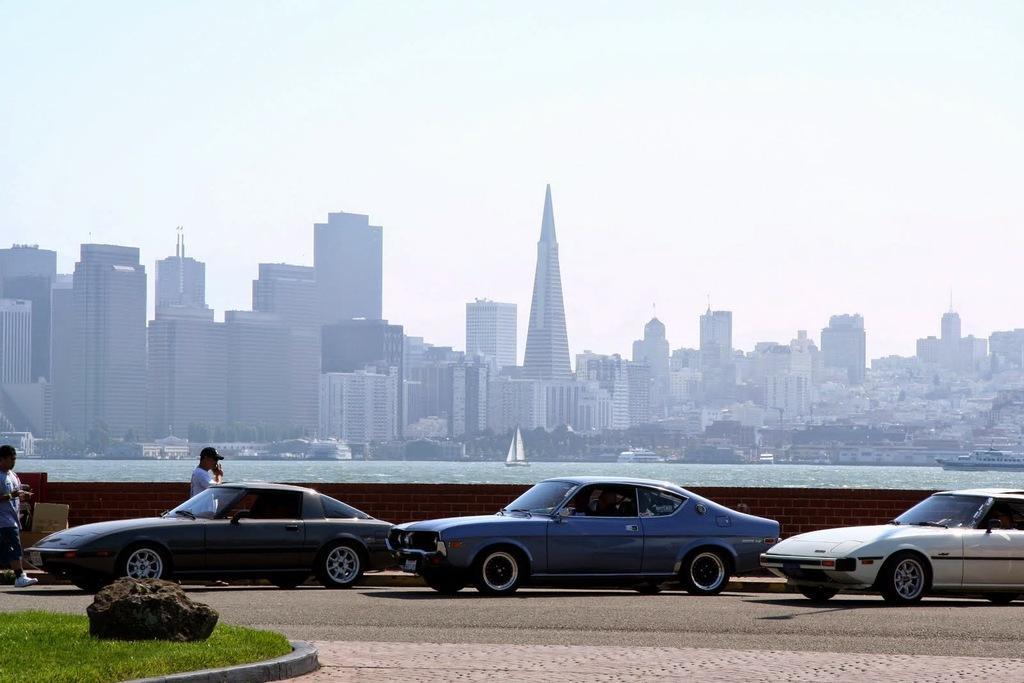Can you describe this image briefly? In this picture we can see grass, a rock and few cars on the road, and we can see few people are walking beside to the cars, in the background we can find few buildings, trees and boats on the water. 